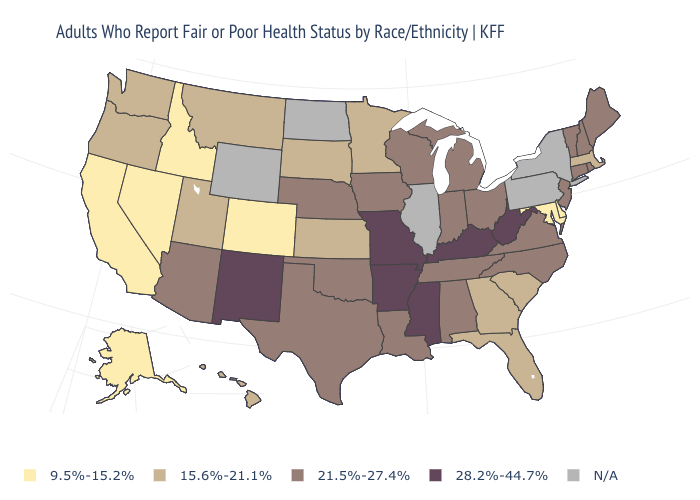What is the highest value in the USA?
Short answer required. 28.2%-44.7%. What is the value of Wyoming?
Short answer required. N/A. Among the states that border Washington , does Oregon have the lowest value?
Be succinct. No. Name the states that have a value in the range 9.5%-15.2%?
Write a very short answer. Alaska, California, Colorado, Delaware, Idaho, Maryland, Nevada. What is the highest value in the USA?
Concise answer only. 28.2%-44.7%. What is the value of Kansas?
Short answer required. 15.6%-21.1%. Name the states that have a value in the range N/A?
Short answer required. Illinois, New York, North Dakota, Pennsylvania, Wyoming. Does Delaware have the lowest value in the South?
Write a very short answer. Yes. Is the legend a continuous bar?
Answer briefly. No. Name the states that have a value in the range 28.2%-44.7%?
Be succinct. Arkansas, Kentucky, Mississippi, Missouri, New Mexico, West Virginia. Does Missouri have the highest value in the MidWest?
Short answer required. Yes. What is the lowest value in the MidWest?
Give a very brief answer. 15.6%-21.1%. Is the legend a continuous bar?
Short answer required. No. Among the states that border Colorado , does Utah have the highest value?
Write a very short answer. No. Name the states that have a value in the range 15.6%-21.1%?
Concise answer only. Florida, Georgia, Hawaii, Kansas, Massachusetts, Minnesota, Montana, Oregon, South Carolina, South Dakota, Utah, Washington. 